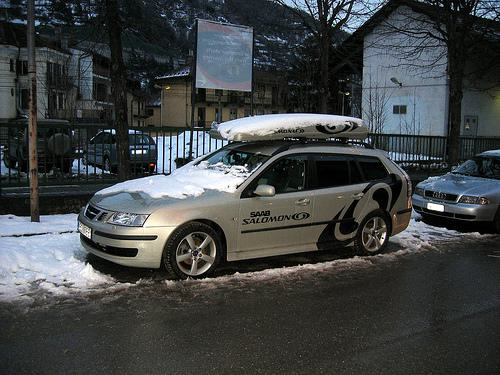Can you tell what time of day it might be from the lighting in the image? The lighting in the image suggests it is either early morning or late afternoon. The light appears soft and not overly harsh, typical of times when the sun is lower in the sky. 